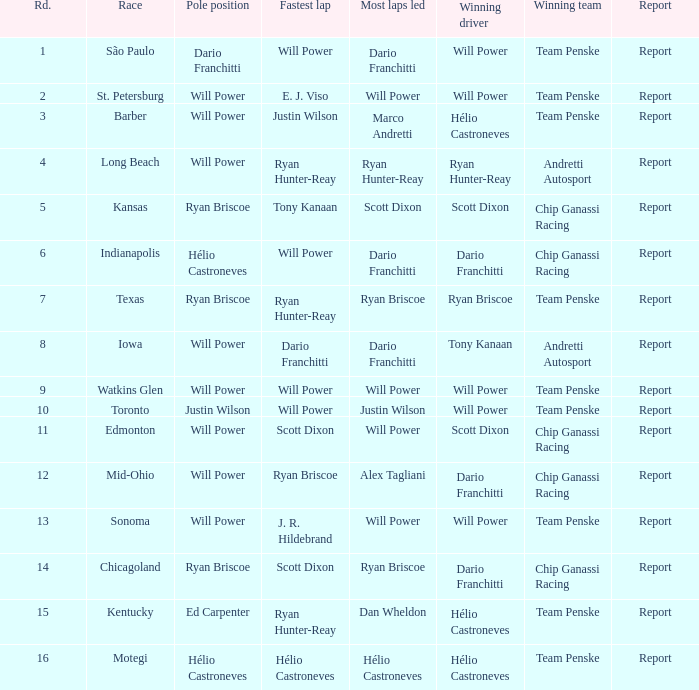What is the report for races where Will Power had both pole position and fastest lap? Report. 